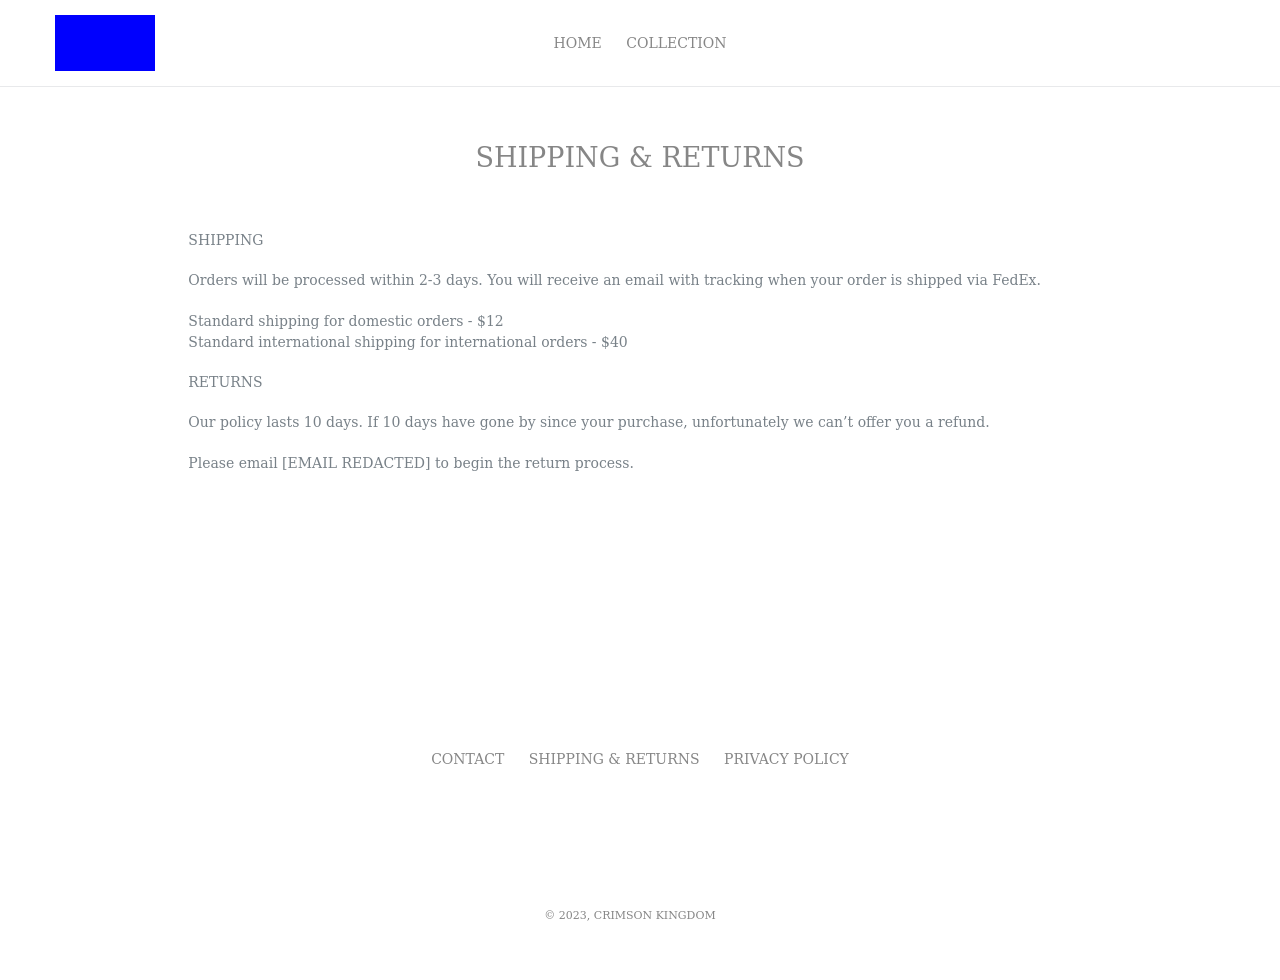What's the procedure for constructing this website from scratch with HTML? To construct a website like the one shown, specifically the page about shipping and returns, you would start by setting up your basic HTML structure. The key elements would include headers for navigation, sectional divs to distinguish between shipping and return policies, and appropriate metadata. Here's an exemplified code snippet:

<!DOCTYPE html>
<html>
<head>
  <title>Shipping & Returns</title>
</head>
<body>
  <header>
    <nav>
      <ul>
        <li><a href='#home'>Home</a></li>
        <li><a href='#shipping'>Shipping</a></li>
        <li><a href='#returns'>Returns</a></li>
      </ul>
    </nav>
  </header>
  <section id='shipping'>
    <h1>Shipping</h1>
    <p>Orders processed within 2-3 days. Domestic shipping at $12, international at $40.</p>
  </section>
  <section id='returns'>
    <h1>Returns</h1>
    <p>10-day return policy. Contact us to initiate the process.</p>
  </section>
</body>
</html>

This code provides a clean layout while maintaining its focus directly on functionality related to displaying the shipping and returns information. 